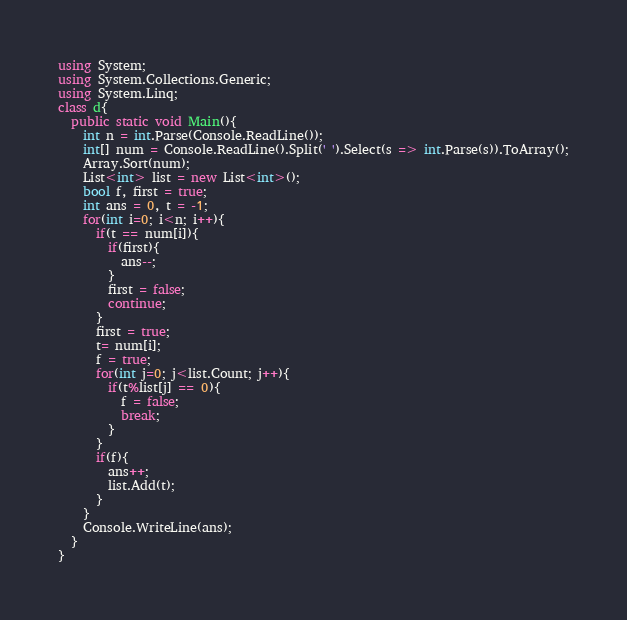<code> <loc_0><loc_0><loc_500><loc_500><_C#_>using System;
using System.Collections.Generic;
using System.Linq;
class d{
  public static void Main(){
    int n = int.Parse(Console.ReadLine());
    int[] num = Console.ReadLine().Split(' ').Select(s => int.Parse(s)).ToArray();
    Array.Sort(num);
    List<int> list = new List<int>();
    bool f, first = true;
    int ans = 0, t = -1;
    for(int i=0; i<n; i++){
      if(t == num[i]){
        if(first){
          ans--;
        }
        first = false;
        continue;
      }
      first = true;
      t= num[i];
      f = true;
      for(int j=0; j<list.Count; j++){
        if(t%list[j] == 0){
          f = false;
          break;
        }
      }
      if(f){
        ans++;
        list.Add(t);
      }
    }
    Console.WriteLine(ans);
  }
}
</code> 